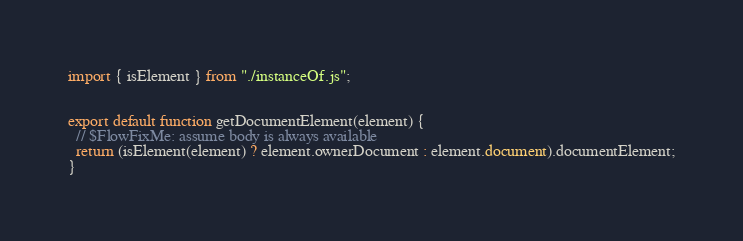Convert code to text. <code><loc_0><loc_0><loc_500><loc_500><_JavaScript_>import { isElement } from "./instanceOf.js";


export default function getDocumentElement(element) {
  // $FlowFixMe: assume body is always available
  return (isElement(element) ? element.ownerDocument : element.document).documentElement;
}
</code> 